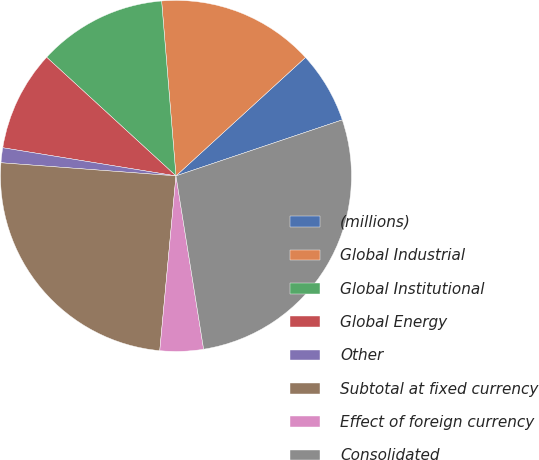Convert chart to OTSL. <chart><loc_0><loc_0><loc_500><loc_500><pie_chart><fcel>(millions)<fcel>Global Industrial<fcel>Global Institutional<fcel>Global Energy<fcel>Other<fcel>Subtotal at fixed currency<fcel>Effect of foreign currency<fcel>Consolidated<nl><fcel>6.62%<fcel>14.51%<fcel>11.88%<fcel>9.25%<fcel>1.37%<fcel>24.72%<fcel>3.99%<fcel>27.65%<nl></chart> 